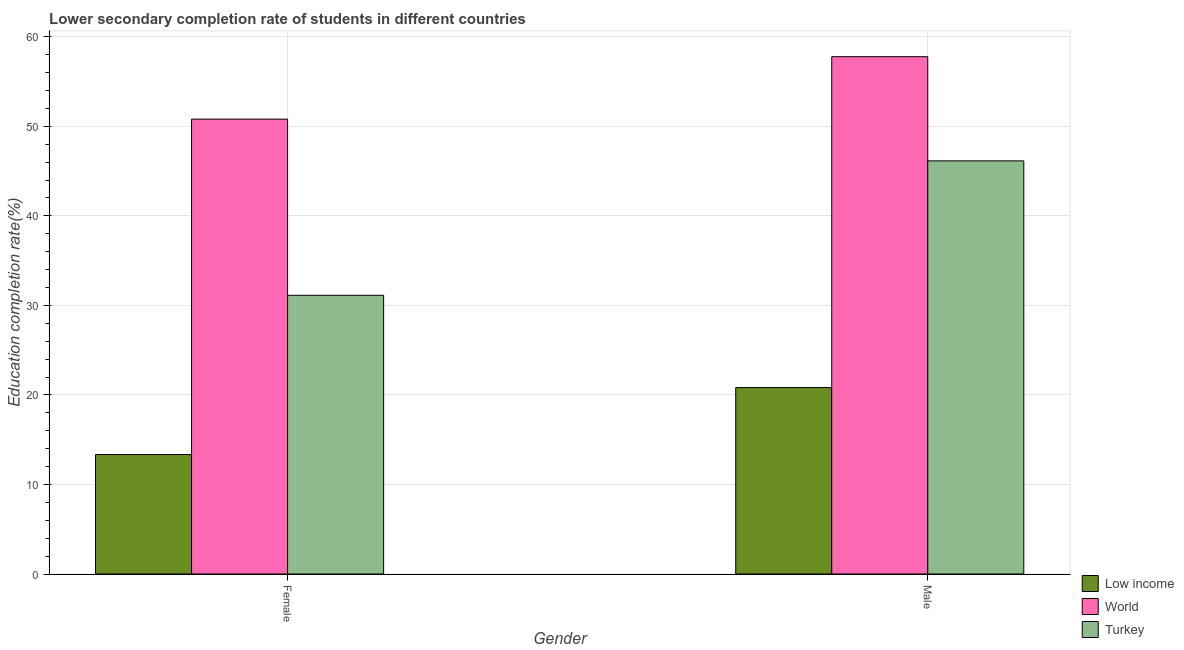Are the number of bars per tick equal to the number of legend labels?
Your answer should be compact. Yes. Are the number of bars on each tick of the X-axis equal?
Provide a succinct answer. Yes. How many bars are there on the 1st tick from the left?
Offer a very short reply. 3. What is the label of the 1st group of bars from the left?
Offer a terse response. Female. What is the education completion rate of female students in Turkey?
Your answer should be very brief. 31.13. Across all countries, what is the maximum education completion rate of female students?
Ensure brevity in your answer.  50.81. Across all countries, what is the minimum education completion rate of female students?
Provide a short and direct response. 13.34. What is the total education completion rate of male students in the graph?
Make the answer very short. 124.75. What is the difference between the education completion rate of female students in World and that in Low income?
Make the answer very short. 37.47. What is the difference between the education completion rate of male students in World and the education completion rate of female students in Low income?
Ensure brevity in your answer.  44.44. What is the average education completion rate of male students per country?
Provide a short and direct response. 41.58. What is the difference between the education completion rate of female students and education completion rate of male students in World?
Your answer should be compact. -6.97. What is the ratio of the education completion rate of female students in World to that in Turkey?
Ensure brevity in your answer.  1.63. What does the 2nd bar from the right in Female represents?
Provide a succinct answer. World. What is the difference between two consecutive major ticks on the Y-axis?
Provide a succinct answer. 10. Are the values on the major ticks of Y-axis written in scientific E-notation?
Give a very brief answer. No. What is the title of the graph?
Your answer should be very brief. Lower secondary completion rate of students in different countries. What is the label or title of the Y-axis?
Offer a very short reply. Education completion rate(%). What is the Education completion rate(%) of Low income in Female?
Your answer should be very brief. 13.34. What is the Education completion rate(%) in World in Female?
Offer a terse response. 50.81. What is the Education completion rate(%) of Turkey in Female?
Keep it short and to the point. 31.13. What is the Education completion rate(%) in Low income in Male?
Ensure brevity in your answer.  20.82. What is the Education completion rate(%) in World in Male?
Provide a succinct answer. 57.78. What is the Education completion rate(%) in Turkey in Male?
Provide a short and direct response. 46.15. Across all Gender, what is the maximum Education completion rate(%) in Low income?
Give a very brief answer. 20.82. Across all Gender, what is the maximum Education completion rate(%) of World?
Ensure brevity in your answer.  57.78. Across all Gender, what is the maximum Education completion rate(%) of Turkey?
Your answer should be very brief. 46.15. Across all Gender, what is the minimum Education completion rate(%) in Low income?
Your answer should be compact. 13.34. Across all Gender, what is the minimum Education completion rate(%) in World?
Offer a terse response. 50.81. Across all Gender, what is the minimum Education completion rate(%) of Turkey?
Your answer should be compact. 31.13. What is the total Education completion rate(%) in Low income in the graph?
Provide a short and direct response. 34.17. What is the total Education completion rate(%) of World in the graph?
Your answer should be very brief. 108.59. What is the total Education completion rate(%) of Turkey in the graph?
Your response must be concise. 77.28. What is the difference between the Education completion rate(%) in Low income in Female and that in Male?
Your answer should be compact. -7.48. What is the difference between the Education completion rate(%) in World in Female and that in Male?
Give a very brief answer. -6.97. What is the difference between the Education completion rate(%) of Turkey in Female and that in Male?
Make the answer very short. -15.02. What is the difference between the Education completion rate(%) in Low income in Female and the Education completion rate(%) in World in Male?
Offer a terse response. -44.44. What is the difference between the Education completion rate(%) in Low income in Female and the Education completion rate(%) in Turkey in Male?
Make the answer very short. -32.81. What is the difference between the Education completion rate(%) of World in Female and the Education completion rate(%) of Turkey in Male?
Ensure brevity in your answer.  4.66. What is the average Education completion rate(%) of Low income per Gender?
Offer a very short reply. 17.08. What is the average Education completion rate(%) of World per Gender?
Your response must be concise. 54.3. What is the average Education completion rate(%) of Turkey per Gender?
Provide a succinct answer. 38.64. What is the difference between the Education completion rate(%) in Low income and Education completion rate(%) in World in Female?
Your answer should be very brief. -37.47. What is the difference between the Education completion rate(%) of Low income and Education completion rate(%) of Turkey in Female?
Provide a short and direct response. -17.79. What is the difference between the Education completion rate(%) in World and Education completion rate(%) in Turkey in Female?
Give a very brief answer. 19.68. What is the difference between the Education completion rate(%) of Low income and Education completion rate(%) of World in Male?
Your response must be concise. -36.96. What is the difference between the Education completion rate(%) of Low income and Education completion rate(%) of Turkey in Male?
Offer a very short reply. -25.32. What is the difference between the Education completion rate(%) in World and Education completion rate(%) in Turkey in Male?
Offer a terse response. 11.64. What is the ratio of the Education completion rate(%) in Low income in Female to that in Male?
Your answer should be very brief. 0.64. What is the ratio of the Education completion rate(%) of World in Female to that in Male?
Offer a very short reply. 0.88. What is the ratio of the Education completion rate(%) in Turkey in Female to that in Male?
Offer a terse response. 0.67. What is the difference between the highest and the second highest Education completion rate(%) in Low income?
Offer a terse response. 7.48. What is the difference between the highest and the second highest Education completion rate(%) of World?
Your answer should be compact. 6.97. What is the difference between the highest and the second highest Education completion rate(%) of Turkey?
Offer a terse response. 15.02. What is the difference between the highest and the lowest Education completion rate(%) of Low income?
Make the answer very short. 7.48. What is the difference between the highest and the lowest Education completion rate(%) of World?
Provide a short and direct response. 6.97. What is the difference between the highest and the lowest Education completion rate(%) of Turkey?
Provide a succinct answer. 15.02. 